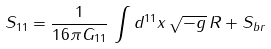Convert formula to latex. <formula><loc_0><loc_0><loc_500><loc_500>S _ { 1 1 } = \frac { 1 } { 1 6 \pi G _ { 1 1 } } \, \int d ^ { 1 1 } x \, \sqrt { - g } \, R + S _ { b r }</formula> 